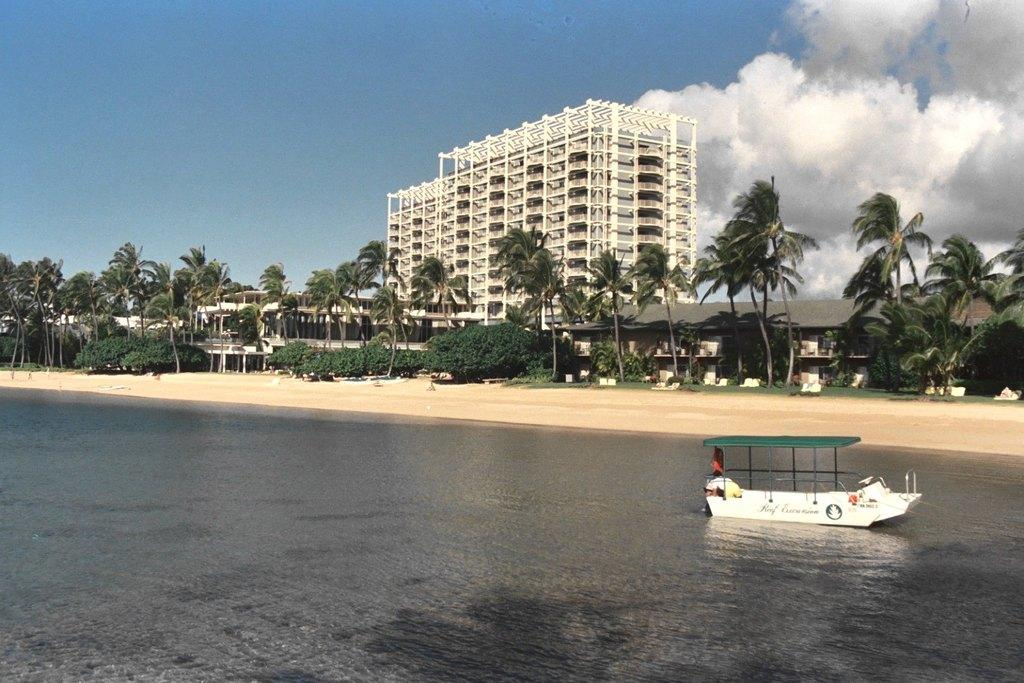What is the main subject of the image? The main subject of the image is a boat. Where is the boat located? The boat is on the water. What can be seen in the background of the image? There are trees, houses, and the sky visible in the background of the image. What level of difficulty is the boat designed for in the image? The image does not provide information about the boat's level of difficulty or intended use. 